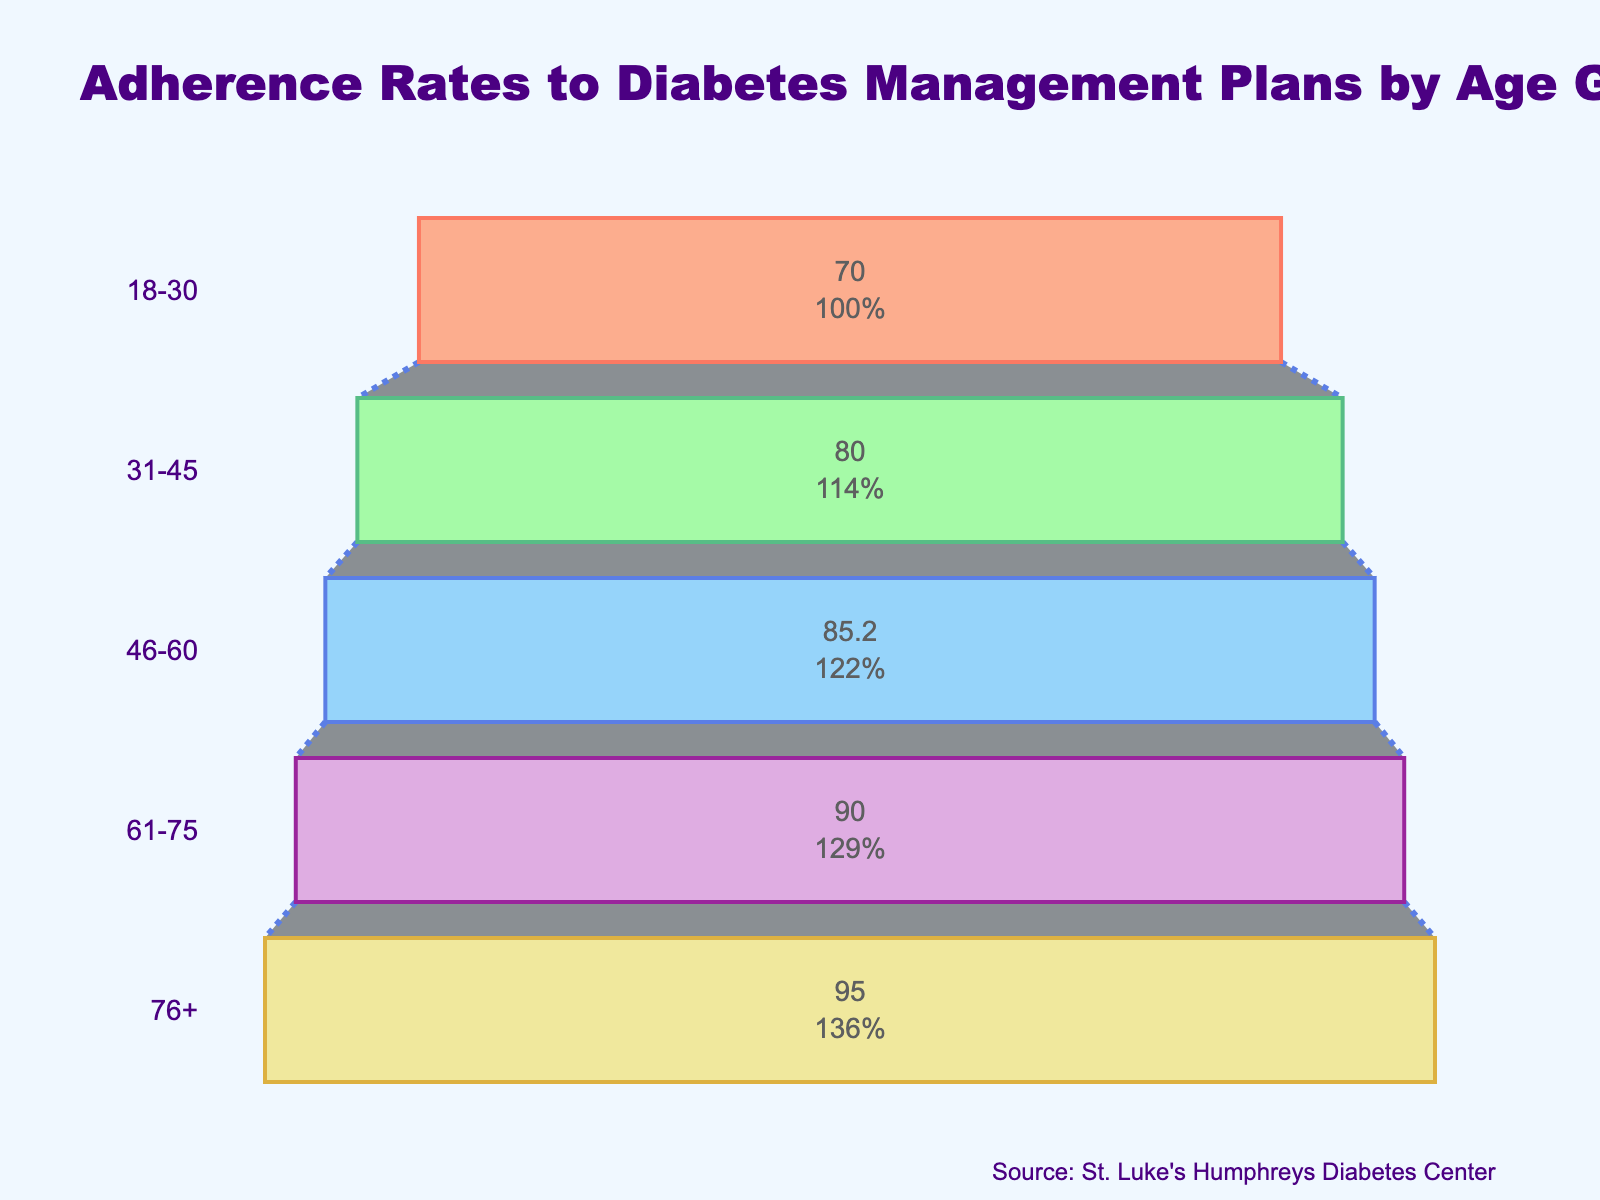what is the title of the figure? The title of the figure is located at the top and usually in larger, bold font. It's meant to summarize what the entire figure is about. In this case, it specifically mentions adherence rates and the relevant age groups.
Answer: Adherence Rates to Diabetes Management Plans by Age Group how many age groups are displayed in the chart? By counting the unique markers or segments in the funnel chart, each labeled with an age group, we can determine the number of age groups represented.
Answer: 5 what is the adherence rate for the 46-60 age group? The adherence rate for each age group is displayed within the funnel segments. For the 46-60 age group, we can directly read off the adherence rate value.
Answer: 85.2% which age group has the highest adherence rate? By comparing the adherence rates displayed within each segment of the funnel chart, we can identify the age group with the highest percentage value.
Answer: 76+ what is the difference in adherence rates between the 31-45 and 61-75 age groups? First, we find the adherence rates for each group (80.0% for 31-45 and 90.0% for 61-75). Then we subtract the smaller rate from the larger rate to get the difference.
Answer: 10% what is the average adherence rate across all age groups? Add the adherence rates of all age groups (70%, 80%, 85.2%, 90%, and 95%) and then divide by the number of groups (5) to get the average.
Answer: 84.04% which groups have an adherence rate greater than 80%? By reviewing the adherence rates displayed for each age group, we can list those with a rate higher than 80%.
Answer: 46-60, 61-75, 76+ how does the adherence rate change as the age increases? Observing the adherence rates from the youngest to the oldest group, we notice the trend of increasing adherence rates as age increases. This is deduced by noting the value of each rate and recognizing the pattern.
Answer: Increases 